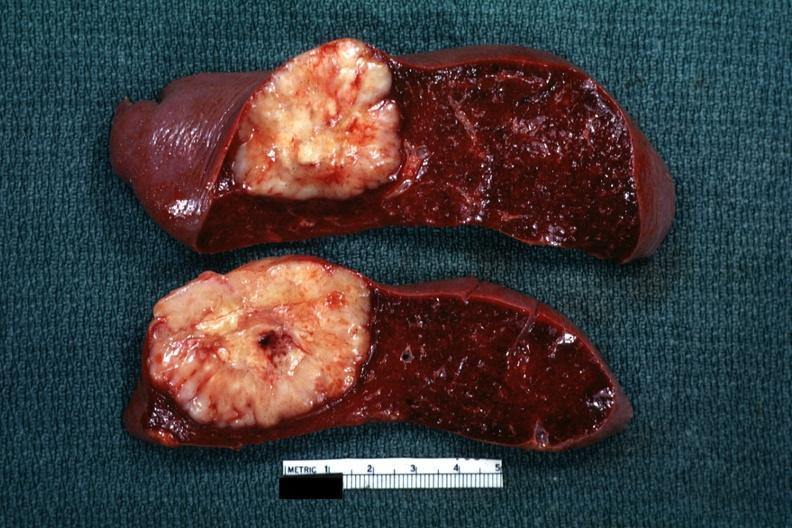what does this image show?
Answer the question using a single word or phrase. Single metastatic appearing lesion is quite large diagnosis was reticulum cell sarcoma 